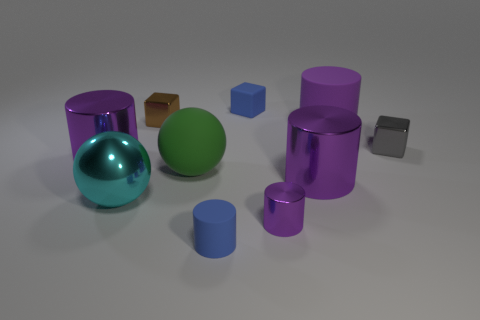Is the color of the metallic sphere the same as the big rubber cylinder?
Keep it short and to the point. No. How many cylinders are either big purple objects or cyan metal objects?
Offer a terse response. 3. What is the material of the tiny block that is both on the right side of the brown metallic block and to the left of the small purple metal object?
Provide a succinct answer. Rubber. There is a small brown block; how many green rubber balls are behind it?
Your response must be concise. 0. Do the large purple cylinder left of the tiny brown block and the tiny cube in front of the big purple rubber cylinder have the same material?
Offer a terse response. Yes. How many things are large cylinders in front of the big purple rubber thing or big cyan objects?
Your answer should be compact. 3. Is the number of tiny metallic cubes left of the big cyan object less than the number of metal things that are in front of the blue matte cylinder?
Your answer should be very brief. No. How many other objects are there of the same size as the green rubber thing?
Offer a terse response. 4. Is the material of the brown block the same as the tiny cylinder that is right of the tiny blue cylinder?
Your answer should be very brief. Yes. How many things are objects behind the big matte cylinder or green matte spheres to the right of the brown object?
Offer a very short reply. 3. 